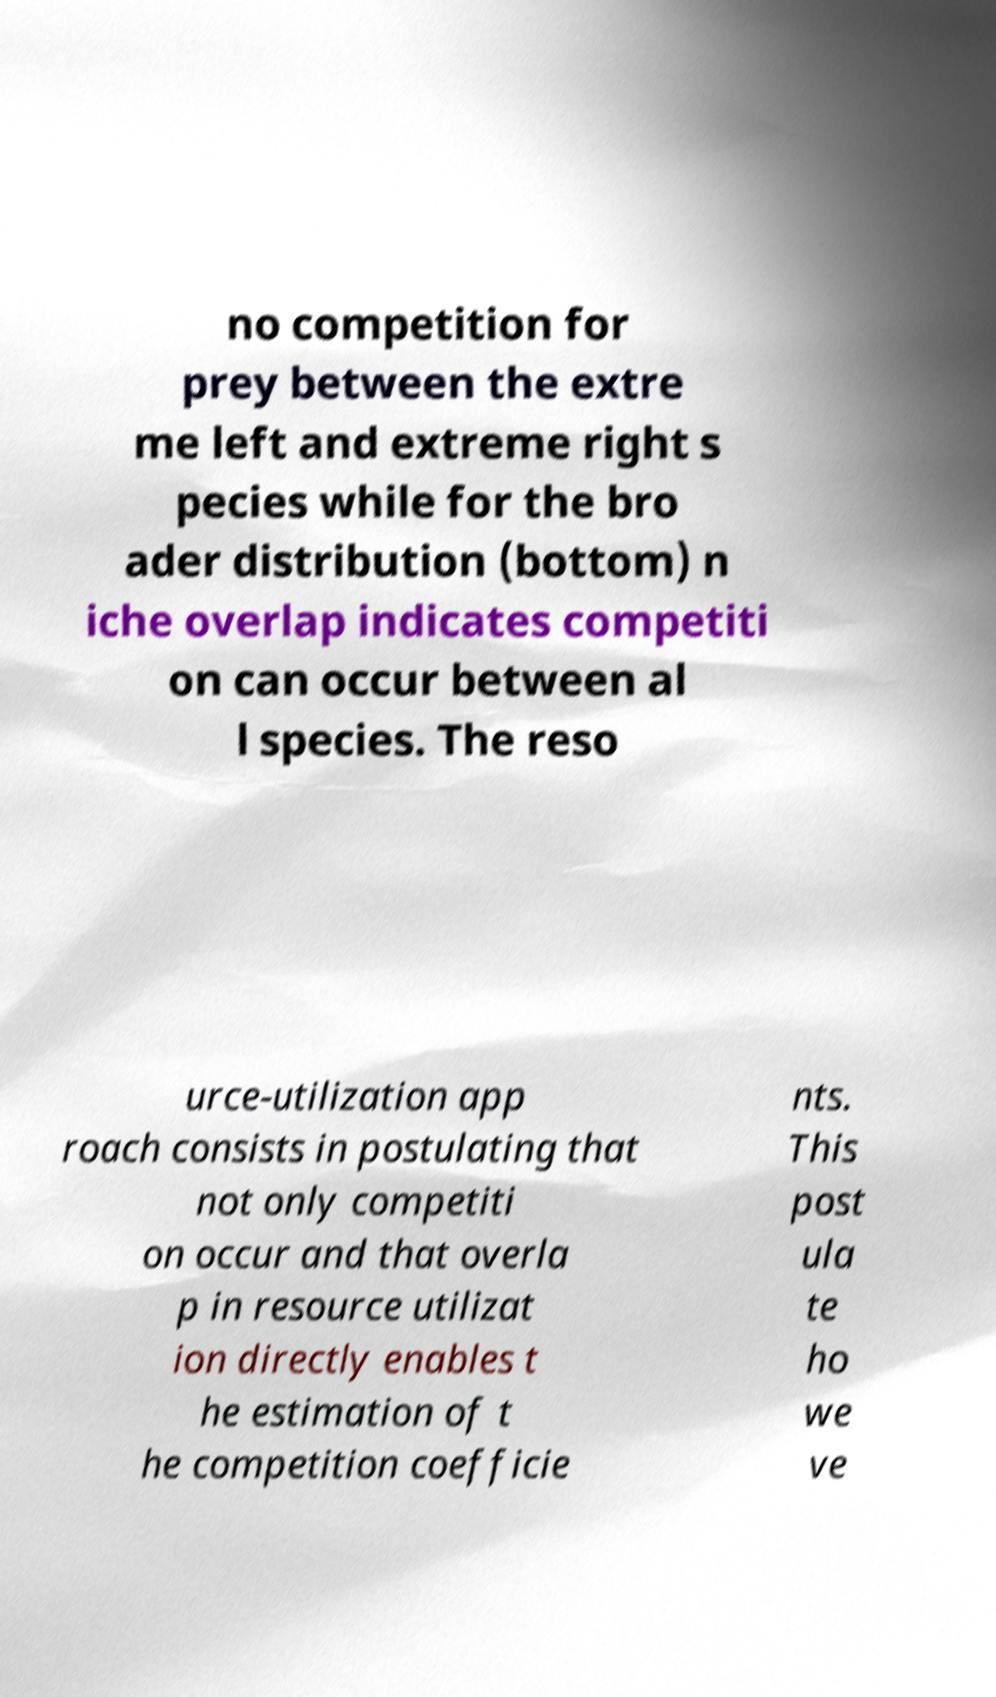Can you read and provide the text displayed in the image?This photo seems to have some interesting text. Can you extract and type it out for me? no competition for prey between the extre me left and extreme right s pecies while for the bro ader distribution (bottom) n iche overlap indicates competiti on can occur between al l species. The reso urce-utilization app roach consists in postulating that not only competiti on occur and that overla p in resource utilizat ion directly enables t he estimation of t he competition coefficie nts. This post ula te ho we ve 